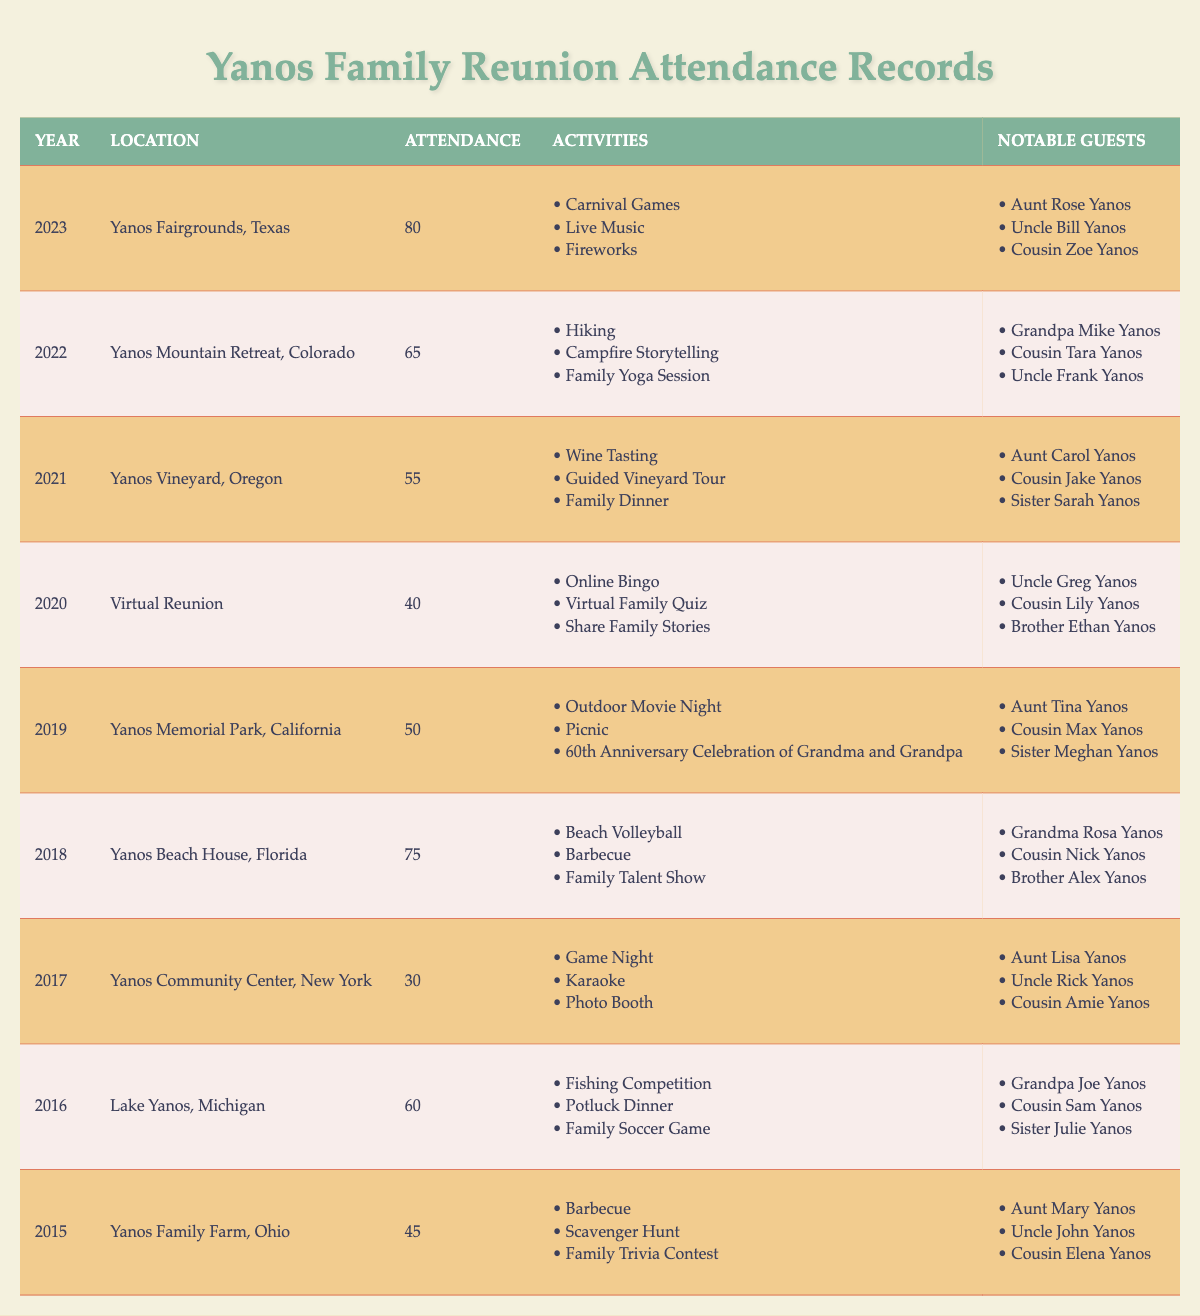What year had the highest attendance? Looking at the attendance numbers for each year, the highest value is 80, which corresponds to the year 2023.
Answer: 2023 What activities took place during the 2018 reunion? The 2018 reunion included Beach Volleyball, Barbecue, and Family Talent Show, as listed under activities for that year.
Answer: Beach Volleyball, Barbecue, Family Talent Show Who were some notable guests at the 2021 reunion? Notable guests for the 2021 reunion included Aunt Carol Yanos, Cousin Jake Yanos, and Sister Sarah Yanos, as shown in the table.
Answer: Aunt Carol Yanos, Cousin Jake Yanos, Sister Sarah Yanos What was the average attendance from 2015 to 2019? The attendances from 2015 to 2019 are: 45, 60, 30, 75, and 50. We sum these (45 + 60 + 30 + 75 + 50 = 260) and divide by the 5 years: 260/5 = 52.
Answer: 52 Was there a reunion held in a virtual format? Yes, there was a reunion held in a virtual format in the year 2020, as indicated in the table.
Answer: Yes In which year did the Yanos family gather at the Yanos Vineyard? The Yanos family gathered at the Yanos Vineyard in Oregon in the year 2021, which is mentioned in the location column for that year.
Answer: 2021 What was the total attendance from 2015 to 2023? Adding the attendance for the years 2015 to 2023 gives: 45 + 60 + 30 + 75 + 50 + 40 + 55 + 65 + 80 = 500.
Answer: 500 Which location had the lowest attendance, and what was it? The lowest attendance was 30, which occurred at the Yanos Community Center, New York, in 2017.
Answer: 30 at Yanos Community Center, New York What year had BBQ as one of its activities? The years that had BBQ as an activity are 2015 and 2018, as both listed BBQ in their activities.
Answer: 2015, 2018 How many different locations were used for reunions from 2015 to 2023? The unique locations for the reunions from 2015 to 2023 are Yanos Family Farm, Lake Yanos, Yanos Community Center, Yanos Beach House, Yanos Memorial Park, Virtual Reunion, Yanos Vineyard, Yanos Mountain Retreat, and Yanos Fairgrounds, making 9 in total.
Answer: 9 